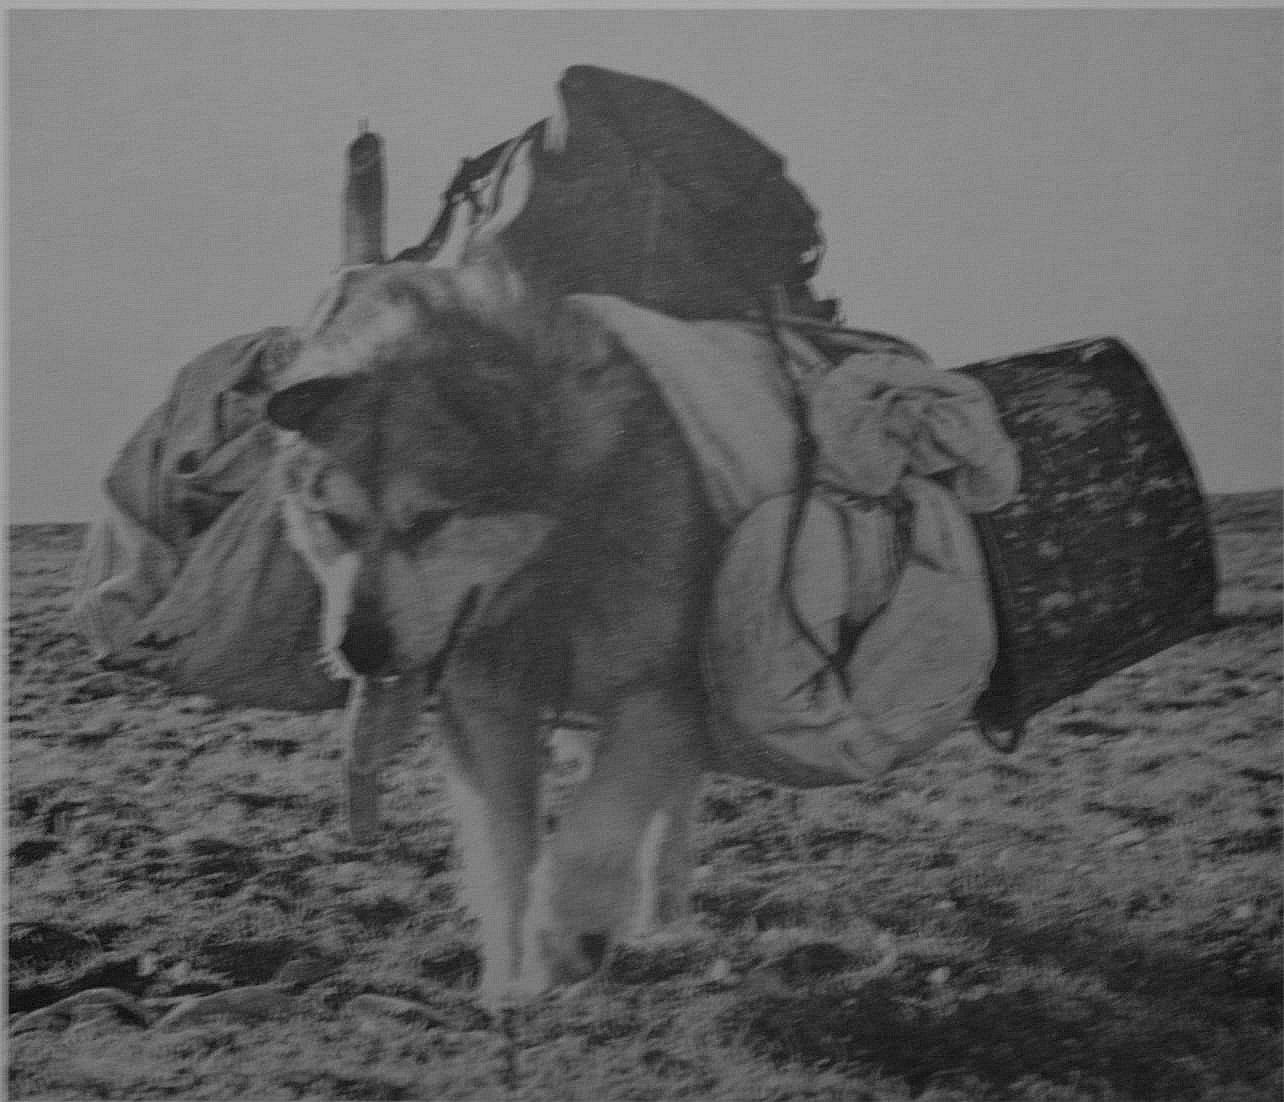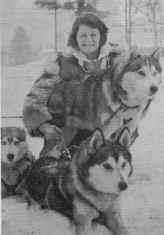The first image is the image on the left, the second image is the image on the right. For the images displayed, is the sentence "An image shows a forward-facing person wearing fur, posing next to at least one forward-facing sled dog." factually correct? Answer yes or no. Yes. The first image is the image on the left, the second image is the image on the right. Assess this claim about the two images: "In at least one image there is a single person facing forward holding their huskey in the snow.". Correct or not? Answer yes or no. Yes. 